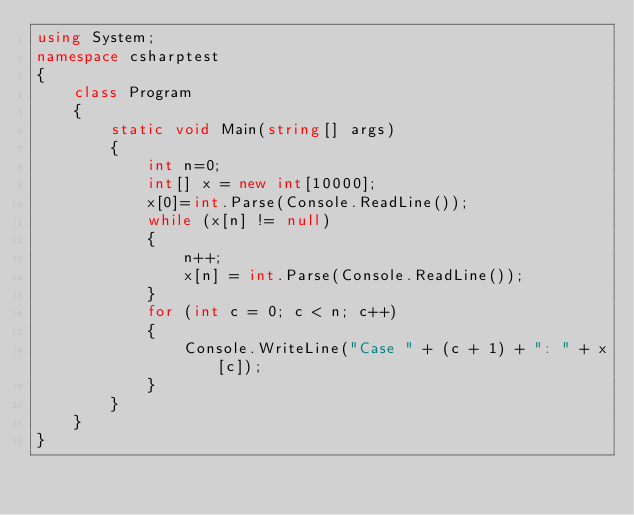<code> <loc_0><loc_0><loc_500><loc_500><_C#_>using System;
namespace csharptest
{
    class Program
    {
        static void Main(string[] args)
        {
            int n=0;
            int[] x = new int[10000];
            x[0]=int.Parse(Console.ReadLine());
            while (x[n] != null)
            {
                n++;
                x[n] = int.Parse(Console.ReadLine());
            }
            for (int c = 0; c < n; c++)
            {
                Console.WriteLine("Case " + (c + 1) + ": " + x[c]);
            }
        }
    }
}</code> 